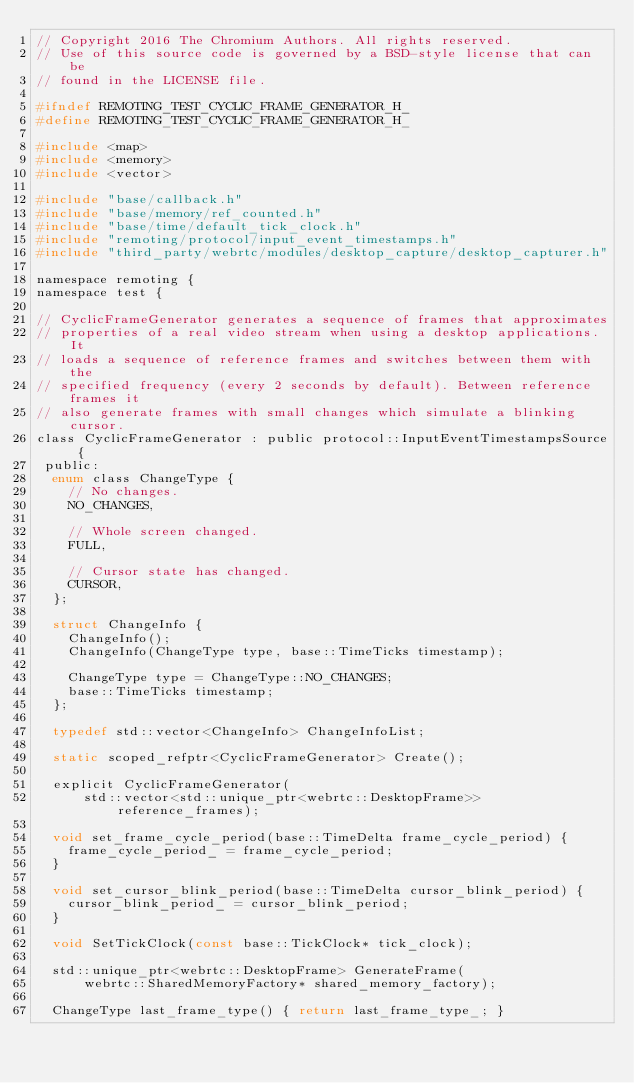<code> <loc_0><loc_0><loc_500><loc_500><_C_>// Copyright 2016 The Chromium Authors. All rights reserved.
// Use of this source code is governed by a BSD-style license that can be
// found in the LICENSE file.

#ifndef REMOTING_TEST_CYCLIC_FRAME_GENERATOR_H_
#define REMOTING_TEST_CYCLIC_FRAME_GENERATOR_H_

#include <map>
#include <memory>
#include <vector>

#include "base/callback.h"
#include "base/memory/ref_counted.h"
#include "base/time/default_tick_clock.h"
#include "remoting/protocol/input_event_timestamps.h"
#include "third_party/webrtc/modules/desktop_capture/desktop_capturer.h"

namespace remoting {
namespace test {

// CyclicFrameGenerator generates a sequence of frames that approximates
// properties of a real video stream when using a desktop applications. It
// loads a sequence of reference frames and switches between them with the
// specified frequency (every 2 seconds by default). Between reference frames it
// also generate frames with small changes which simulate a blinking cursor.
class CyclicFrameGenerator : public protocol::InputEventTimestampsSource {
 public:
  enum class ChangeType {
    // No changes.
    NO_CHANGES,

    // Whole screen changed.
    FULL,

    // Cursor state has changed.
    CURSOR,
  };

  struct ChangeInfo {
    ChangeInfo();
    ChangeInfo(ChangeType type, base::TimeTicks timestamp);

    ChangeType type = ChangeType::NO_CHANGES;
    base::TimeTicks timestamp;
  };

  typedef std::vector<ChangeInfo> ChangeInfoList;

  static scoped_refptr<CyclicFrameGenerator> Create();

  explicit CyclicFrameGenerator(
      std::vector<std::unique_ptr<webrtc::DesktopFrame>> reference_frames);

  void set_frame_cycle_period(base::TimeDelta frame_cycle_period) {
    frame_cycle_period_ = frame_cycle_period;
  }

  void set_cursor_blink_period(base::TimeDelta cursor_blink_period) {
    cursor_blink_period_ = cursor_blink_period;
  }

  void SetTickClock(const base::TickClock* tick_clock);

  std::unique_ptr<webrtc::DesktopFrame> GenerateFrame(
      webrtc::SharedMemoryFactory* shared_memory_factory);

  ChangeType last_frame_type() { return last_frame_type_; }
</code> 